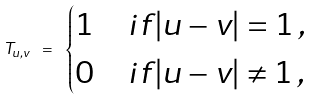Convert formula to latex. <formula><loc_0><loc_0><loc_500><loc_500>T _ { u , v } \ = \ \begin{cases} 1 & i f | u - v | = 1 \, , \\ 0 & i f | u - v | \neq 1 \, , \end{cases}</formula> 